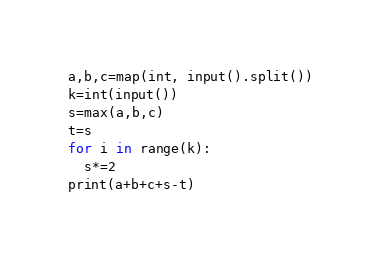Convert code to text. <code><loc_0><loc_0><loc_500><loc_500><_Python_>a,b,c=map(int, input().split())
k=int(input())
s=max(a,b,c)
t=s
for i in range(k):
  s*=2
print(a+b+c+s-t)</code> 